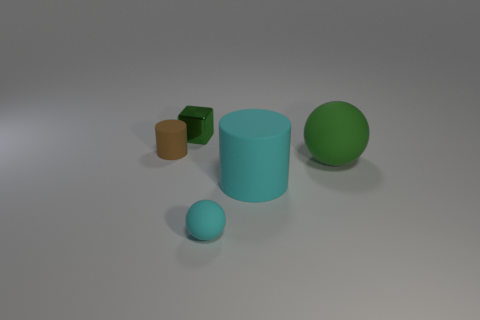Add 4 tiny cyan matte objects. How many objects exist? 9 Subtract all blocks. How many objects are left? 4 Subtract 0 gray blocks. How many objects are left? 5 Subtract all tiny cyan objects. Subtract all small balls. How many objects are left? 3 Add 4 big green balls. How many big green balls are left? 5 Add 1 big green spheres. How many big green spheres exist? 2 